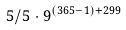<formula> <loc_0><loc_0><loc_500><loc_500>5 / 5 \cdot 9 ^ { ( 3 6 5 - 1 ) + 2 9 9 }</formula> 